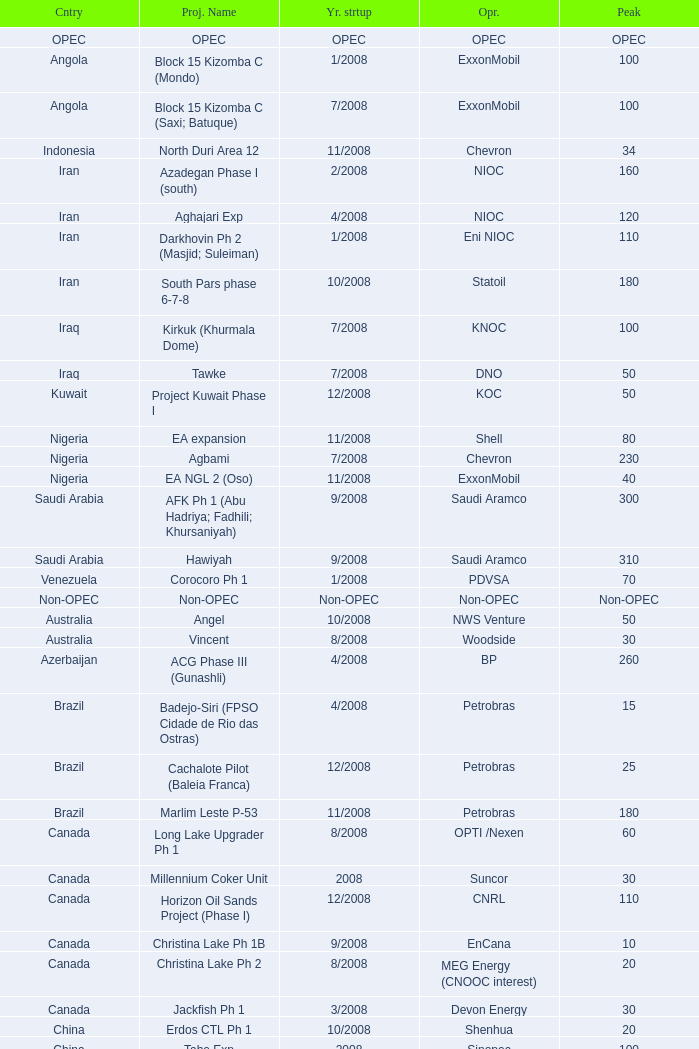What is the Project Name with a Country that is opec? OPEC. 